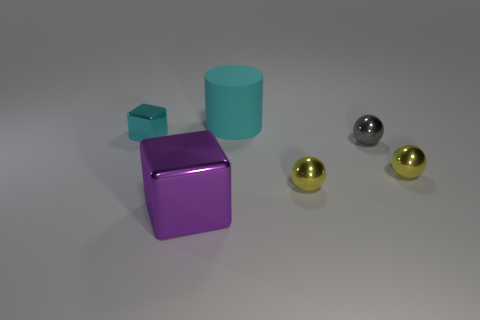How many other things are the same color as the cylinder?
Provide a short and direct response. 1. Is the material of the cylinder the same as the small cyan thing?
Provide a short and direct response. No. What number of cyan objects are rubber cylinders or tiny spheres?
Your answer should be compact. 1. Are there more big cyan cylinders behind the big cyan matte cylinder than large purple things?
Offer a terse response. No. Are there any big shiny things of the same color as the big matte thing?
Provide a short and direct response. No. What size is the gray ball?
Offer a very short reply. Small. Do the big shiny thing and the cylinder have the same color?
Ensure brevity in your answer.  No. How many objects are yellow metallic cylinders or objects that are right of the cyan matte thing?
Provide a short and direct response. 3. There is a gray ball in front of the cyan object that is in front of the big rubber thing; how many tiny gray spheres are in front of it?
Provide a short and direct response. 0. There is a cube that is the same color as the matte thing; what is it made of?
Ensure brevity in your answer.  Metal. 